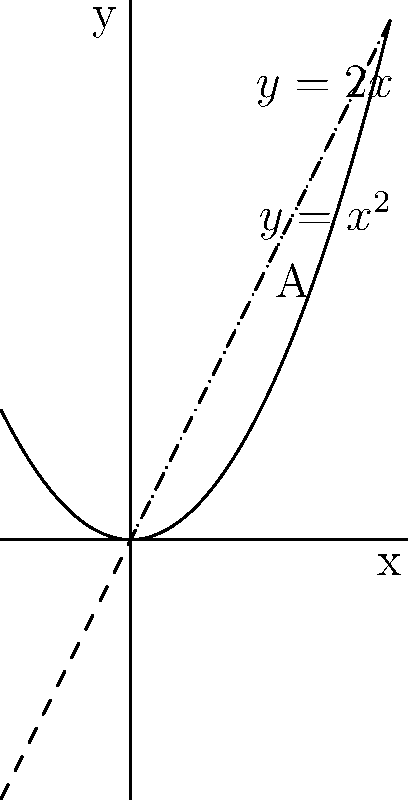Consider the functions $f(x) = x^2$ and $g(x) = 2x$. Calculate the area of the region bounded by these two functions between their points of intersection. Let's approach this step-by-step:

1) First, we need to find the points of intersection. We can do this by setting the functions equal to each other:

   $x^2 = 2x$

2) Rearranging the equation:

   $x^2 - 2x = 0$
   $x(x - 2) = 0$

3) Solving this, we get $x = 0$ and $x = 2$. These are our points of intersection.

4) To find the area, we need to integrate the difference between the upper and lower functions from 0 to 2:

   $A = \int_0^2 (2x - x^2) dx$

5) Let's solve this integral:

   $A = \int_0^2 (2x - x^2) dx = [x^2 - \frac{x^3}{3}]_0^2$

6) Evaluating at the limits:

   $A = (2^2 - \frac{2^3}{3}) - (0^2 - \frac{0^3}{3})$
      $= (4 - \frac{8}{3}) - 0$
      $= \frac{12}{3} - \frac{8}{3}$
      $= \frac{4}{3}$

Therefore, the area between the two functions is $\frac{4}{3}$ square units.
Answer: $\frac{4}{3}$ square units 